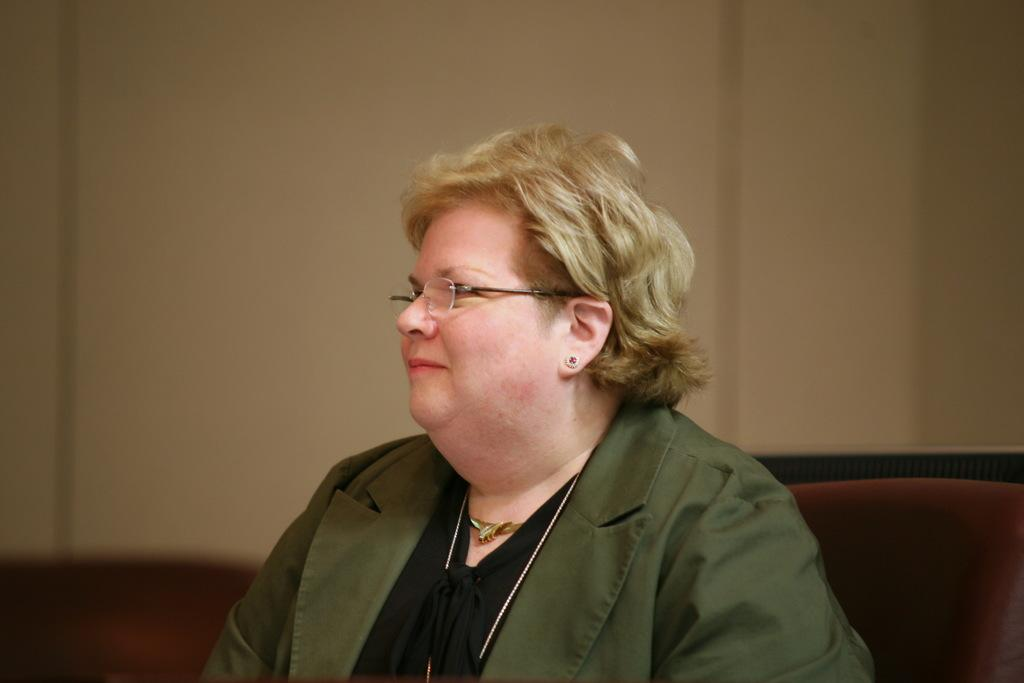Who is the main subject in the image? There is a woman at the bottom of the image. What is the woman wearing? The woman is wearing a spectacle. What is the woman doing in the image? The woman is sitting. What can be seen in the background of the image? There is a wall in the background of the image. What type of soap is the woman using in the image? There is no soap present in the image; the woman is wearing a spectacle and sitting. In which direction is the woman facing in the image? The provided facts do not specify the direction the woman is facing in the image. 